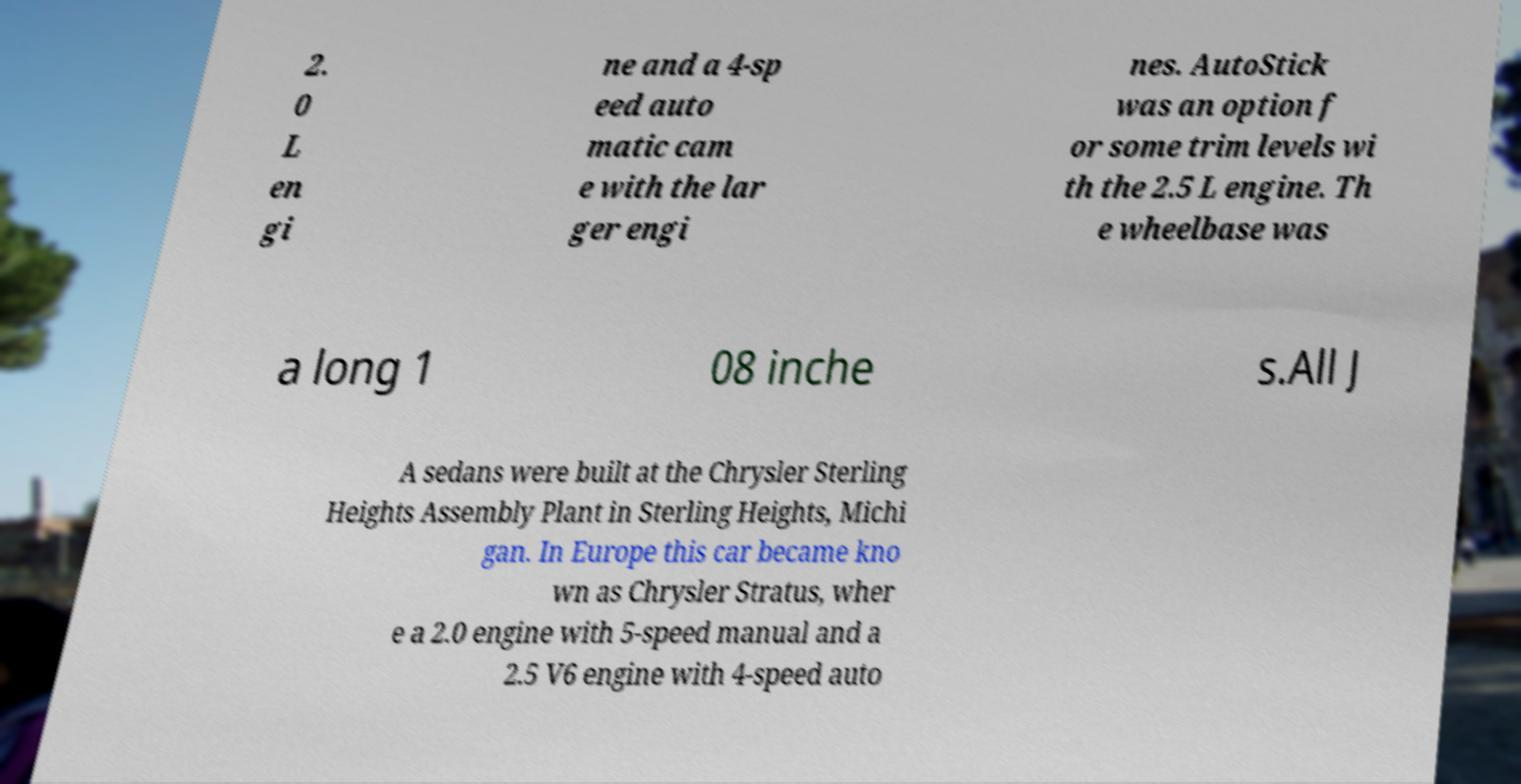Please read and relay the text visible in this image. What does it say? 2. 0 L en gi ne and a 4-sp eed auto matic cam e with the lar ger engi nes. AutoStick was an option f or some trim levels wi th the 2.5 L engine. Th e wheelbase was a long 1 08 inche s.All J A sedans were built at the Chrysler Sterling Heights Assembly Plant in Sterling Heights, Michi gan. In Europe this car became kno wn as Chrysler Stratus, wher e a 2.0 engine with 5-speed manual and a 2.5 V6 engine with 4-speed auto 